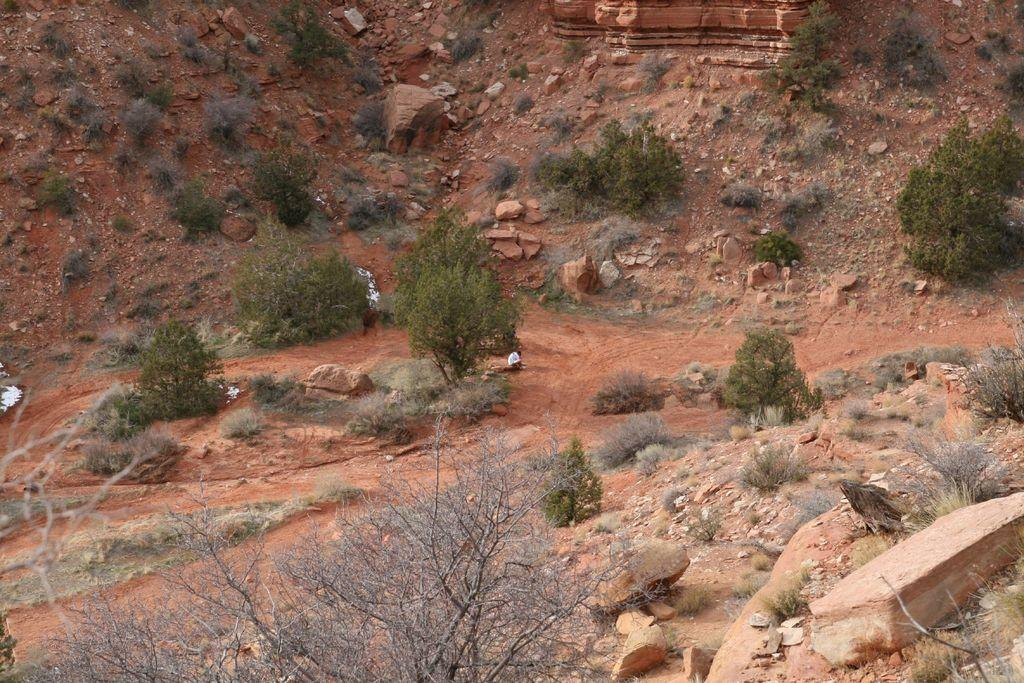What type of vegetation can be seen in the image? There are plants and trees in the image. What other objects can be seen in the image? There are stones in the image. What is visible at the top of the image? There is a hill visible at the top of the image. How many bricks are used to build the trees in the image? There are no bricks used to build the trees in the image; they are natural vegetation. What color are the toes of the plants in the image? There are no toes present in the image, as plants do not have toes. 